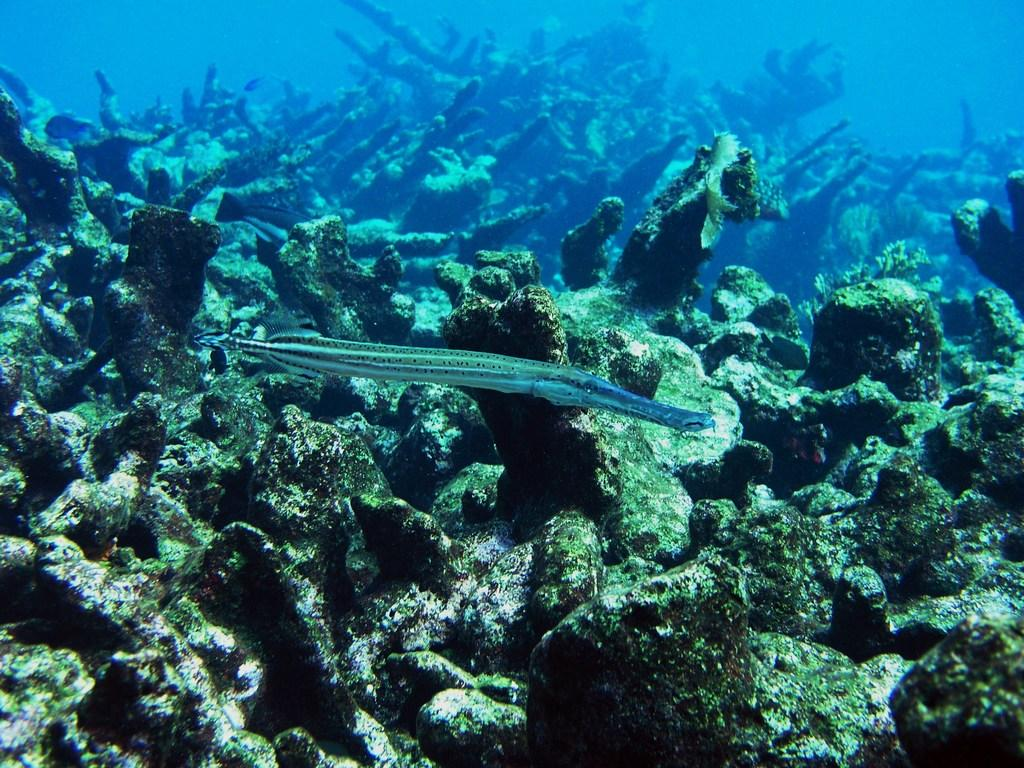What type of animal is present in the image? There is a fish in the image. What other objects can be seen in the image? There are stones and plants in the water in the image. Where is the scarecrow located in the image? There is no scarecrow present in the image. What direction is the fruit facing in the image? There is no fruit present in the image. 